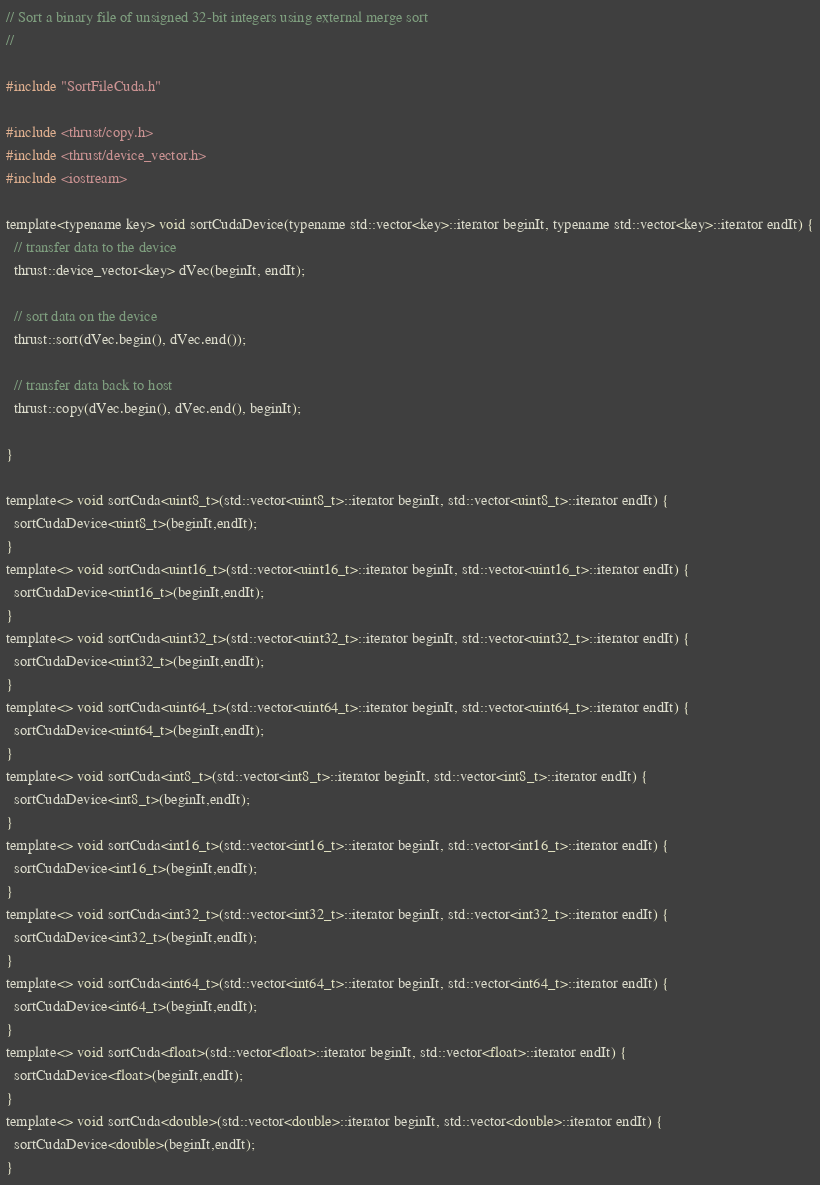<code> <loc_0><loc_0><loc_500><loc_500><_Cuda_>// Sort a binary file of unsigned 32-bit integers using external merge sort
//

#include "SortFileCuda.h"

#include <thrust/copy.h>
#include <thrust/device_vector.h>
#include <iostream>

template<typename key> void sortCudaDevice(typename std::vector<key>::iterator beginIt, typename std::vector<key>::iterator endIt) {
  // transfer data to the device
  thrust::device_vector<key> dVec(beginIt, endIt);

  // sort data on the device
  thrust::sort(dVec.begin(), dVec.end());

  // transfer data back to host
  thrust::copy(dVec.begin(), dVec.end(), beginIt);
  
}

template<> void sortCuda<uint8_t>(std::vector<uint8_t>::iterator beginIt, std::vector<uint8_t>::iterator endIt) {
  sortCudaDevice<uint8_t>(beginIt,endIt);
}
template<> void sortCuda<uint16_t>(std::vector<uint16_t>::iterator beginIt, std::vector<uint16_t>::iterator endIt) {
  sortCudaDevice<uint16_t>(beginIt,endIt);
}
template<> void sortCuda<uint32_t>(std::vector<uint32_t>::iterator beginIt, std::vector<uint32_t>::iterator endIt) {
  sortCudaDevice<uint32_t>(beginIt,endIt);
}
template<> void sortCuda<uint64_t>(std::vector<uint64_t>::iterator beginIt, std::vector<uint64_t>::iterator endIt) {
  sortCudaDevice<uint64_t>(beginIt,endIt);
}
template<> void sortCuda<int8_t>(std::vector<int8_t>::iterator beginIt, std::vector<int8_t>::iterator endIt) {
  sortCudaDevice<int8_t>(beginIt,endIt);
}
template<> void sortCuda<int16_t>(std::vector<int16_t>::iterator beginIt, std::vector<int16_t>::iterator endIt) {
  sortCudaDevice<int16_t>(beginIt,endIt);
}
template<> void sortCuda<int32_t>(std::vector<int32_t>::iterator beginIt, std::vector<int32_t>::iterator endIt) {
  sortCudaDevice<int32_t>(beginIt,endIt);
}
template<> void sortCuda<int64_t>(std::vector<int64_t>::iterator beginIt, std::vector<int64_t>::iterator endIt) {
  sortCudaDevice<int64_t>(beginIt,endIt);
}
template<> void sortCuda<float>(std::vector<float>::iterator beginIt, std::vector<float>::iterator endIt) {
  sortCudaDevice<float>(beginIt,endIt);
}
template<> void sortCuda<double>(std::vector<double>::iterator beginIt, std::vector<double>::iterator endIt) {
  sortCudaDevice<double>(beginIt,endIt);
}</code> 